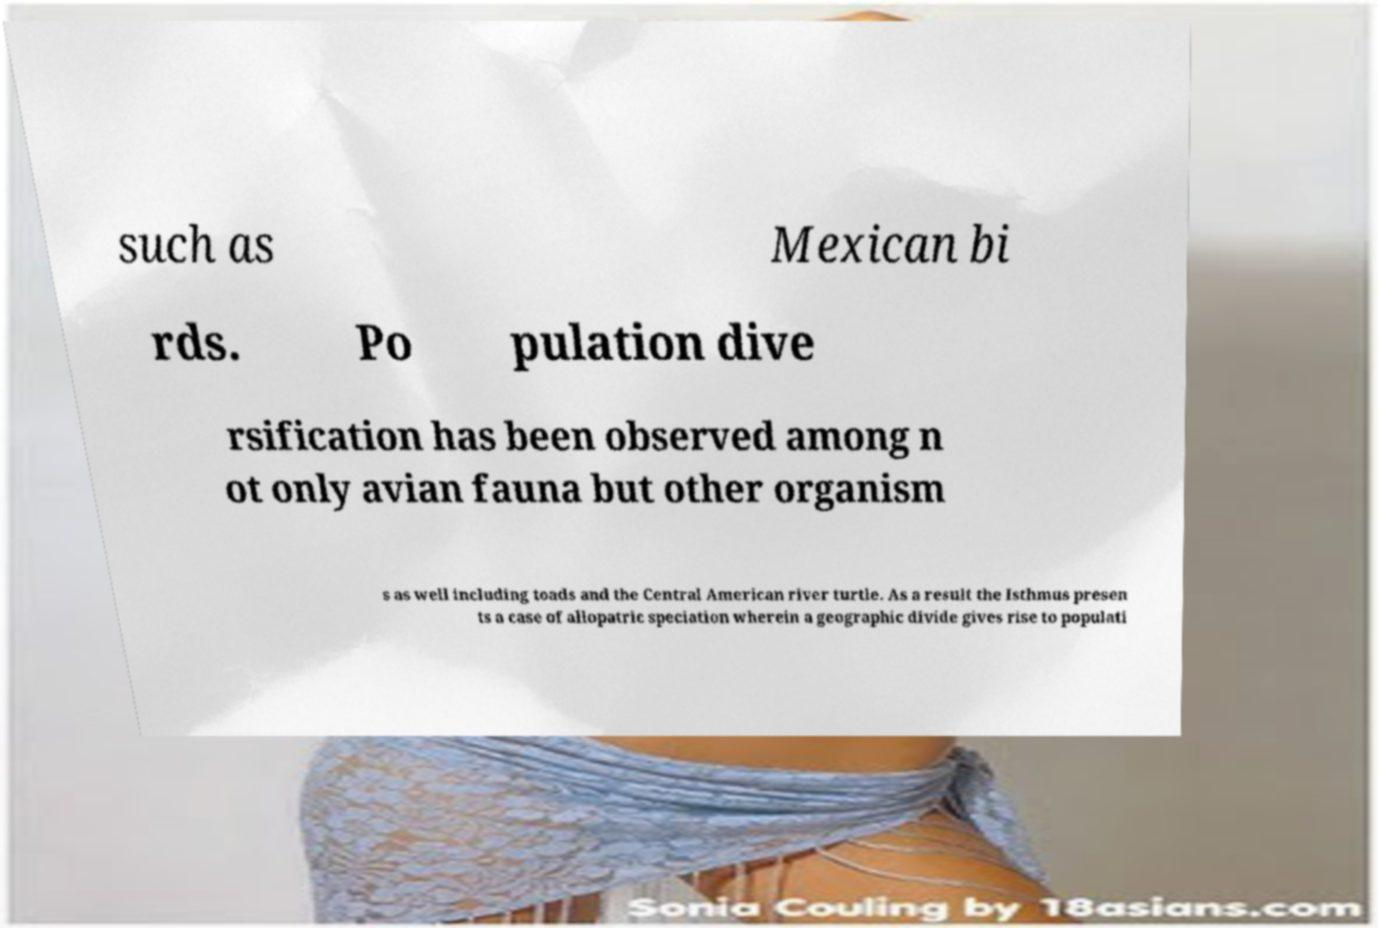What messages or text are displayed in this image? I need them in a readable, typed format. such as Mexican bi rds. Po pulation dive rsification has been observed among n ot only avian fauna but other organism s as well including toads and the Central American river turtle. As a result the Isthmus presen ts a case of allopatric speciation wherein a geographic divide gives rise to populati 